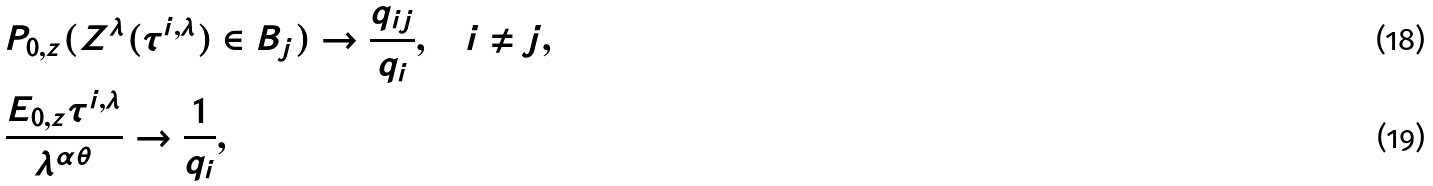<formula> <loc_0><loc_0><loc_500><loc_500>& P _ { 0 , z } ( Z ^ { \lambda } ( \tau ^ { i , \lambda } ) \in B _ { j } ) \to \frac { q _ { i j } } { q _ { i } } , \quad i \neq j , \\ & \frac { E _ { 0 , z } \tau ^ { i , \lambda } } { \lambda ^ { \alpha \theta } } \to \frac { 1 } { q _ { i } } ,</formula> 